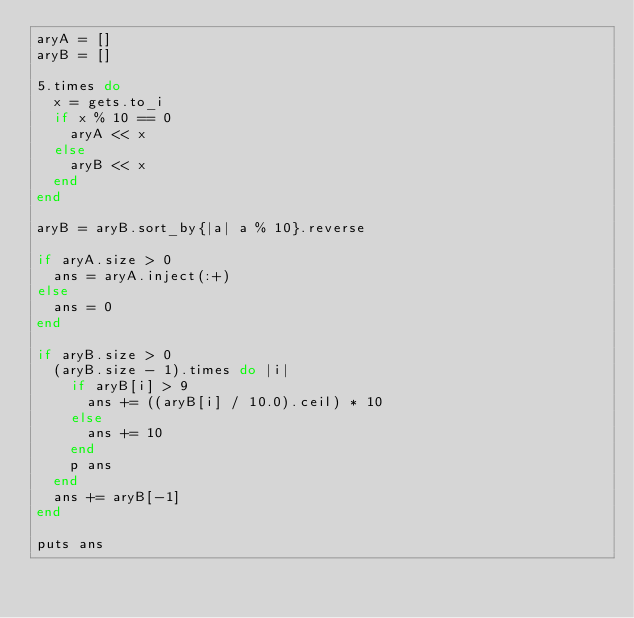<code> <loc_0><loc_0><loc_500><loc_500><_Ruby_>aryA = []
aryB = []

5.times do
  x = gets.to_i
  if x % 10 == 0
    aryA << x
  else
    aryB << x
  end
end

aryB = aryB.sort_by{|a| a % 10}.reverse

if aryA.size > 0
  ans = aryA.inject(:+)
else
  ans = 0
end

if aryB.size > 0
  (aryB.size - 1).times do |i|
    if aryB[i] > 9
      ans += ((aryB[i] / 10.0).ceil) * 10
    else
      ans += 10
    end
    p ans
  end
  ans += aryB[-1]
end

puts ans
</code> 